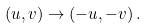Convert formula to latex. <formula><loc_0><loc_0><loc_500><loc_500>( u , v ) \rightarrow ( - u , - v ) \, .</formula> 